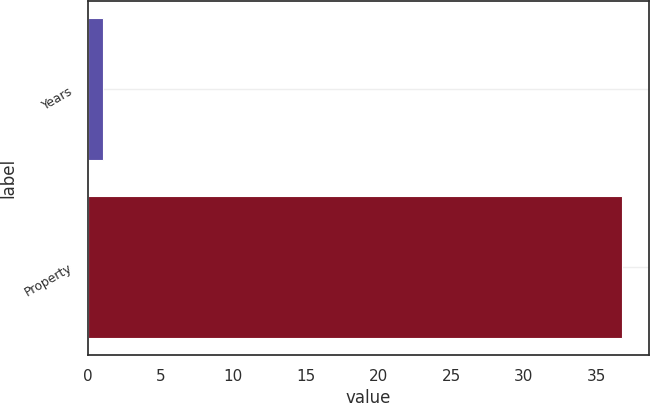Convert chart to OTSL. <chart><loc_0><loc_0><loc_500><loc_500><bar_chart><fcel>Years<fcel>Property<nl><fcel>1<fcel>36.8<nl></chart> 